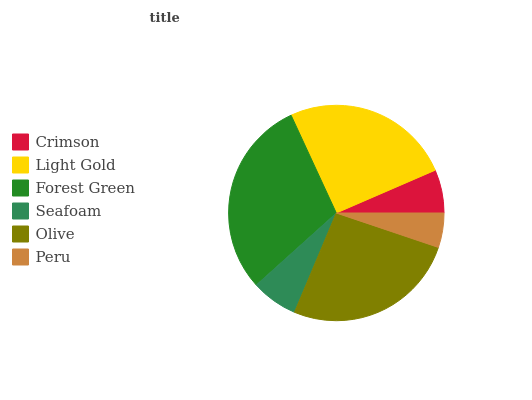Is Peru the minimum?
Answer yes or no. Yes. Is Forest Green the maximum?
Answer yes or no. Yes. Is Light Gold the minimum?
Answer yes or no. No. Is Light Gold the maximum?
Answer yes or no. No. Is Light Gold greater than Crimson?
Answer yes or no. Yes. Is Crimson less than Light Gold?
Answer yes or no. Yes. Is Crimson greater than Light Gold?
Answer yes or no. No. Is Light Gold less than Crimson?
Answer yes or no. No. Is Light Gold the high median?
Answer yes or no. Yes. Is Seafoam the low median?
Answer yes or no. Yes. Is Seafoam the high median?
Answer yes or no. No. Is Light Gold the low median?
Answer yes or no. No. 